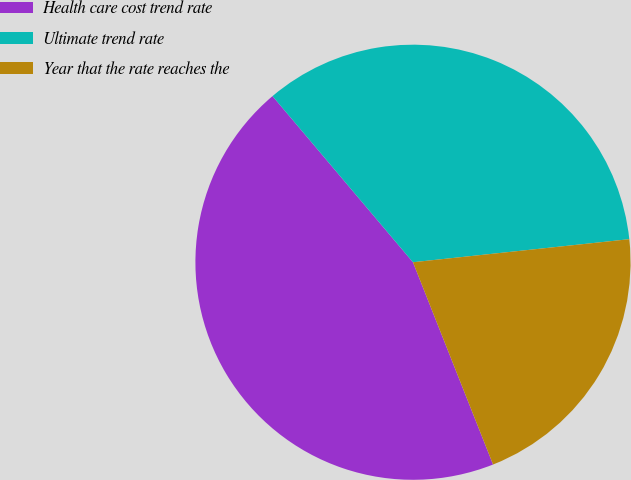Convert chart. <chart><loc_0><loc_0><loc_500><loc_500><pie_chart><fcel>Health care cost trend rate<fcel>Ultimate trend rate<fcel>Year that the rate reaches the<nl><fcel>44.83%<fcel>34.48%<fcel>20.69%<nl></chart> 